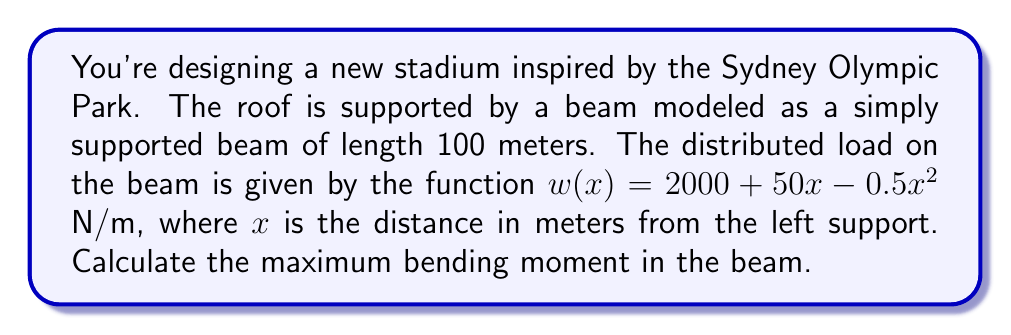Can you solve this math problem? To find the maximum bending moment, we'll follow these steps:

1) First, we need to find the reaction forces at the supports. For a simply supported beam, we can use the equilibrium equations.

2) The total load on the beam is given by:

   $$W = \int_0^{100} w(x) dx = \int_0^{100} (2000 + 50x - 0.5x^2) dx$$
   
   $$W = [2000x + 25x^2 - \frac{1}{6}x^3]_0^{100} = 200000 + 250000 - 166666.67 = 283333.33 \text{ N}$$

3) Due to symmetry, each support reaction will be half of this:

   $$R_A = R_B = \frac{283333.33}{2} = 141666.67 \text{ N}$$

4) The bending moment at any point $x$ is given by:

   $$M(x) = R_A \cdot x - \int_0^x (2000 + 50t - 0.5t^2) \cdot (x-t) dt$$

5) Evaluating this integral:

   $$M(x) = 141666.67x - [2000tx - 1000t^2 + \frac{25}{3}t^3 - \frac{1}{12}t^4]_0^x$$
   
   $$M(x) = 141666.67x - (2000x^2 - 1000x^2 + \frac{25}{3}x^3 - \frac{1}{12}x^4)$$
   
   $$M(x) = 141666.67x - 1000x^2 - \frac{25}{3}x^3 + \frac{1}{12}x^4$$

6) To find the maximum moment, we differentiate $M(x)$ and set it to zero:

   $$\frac{dM}{dx} = 141666.67 - 2000x - 25x^2 + \frac{1}{3}x^3 = 0$$

7) This cubic equation can be solved numerically. The solution in the range 0 to 100 is approximately $x = 50$ m.

8) The maximum bending moment occurs at $x = 50$ m. Substituting this back into the moment equation:

   $$M_{max} = M(50) = 141666.67(50) - 1000(50^2) - \frac{25}{3}(50^3) + \frac{1}{12}(50^4)$$
   
   $$M_{max} = 7083333.5 - 2500000 - 1041666.67 + 520833.33 = 4062500.16 \text{ N·m}$$
Answer: 4062500.16 N·m 